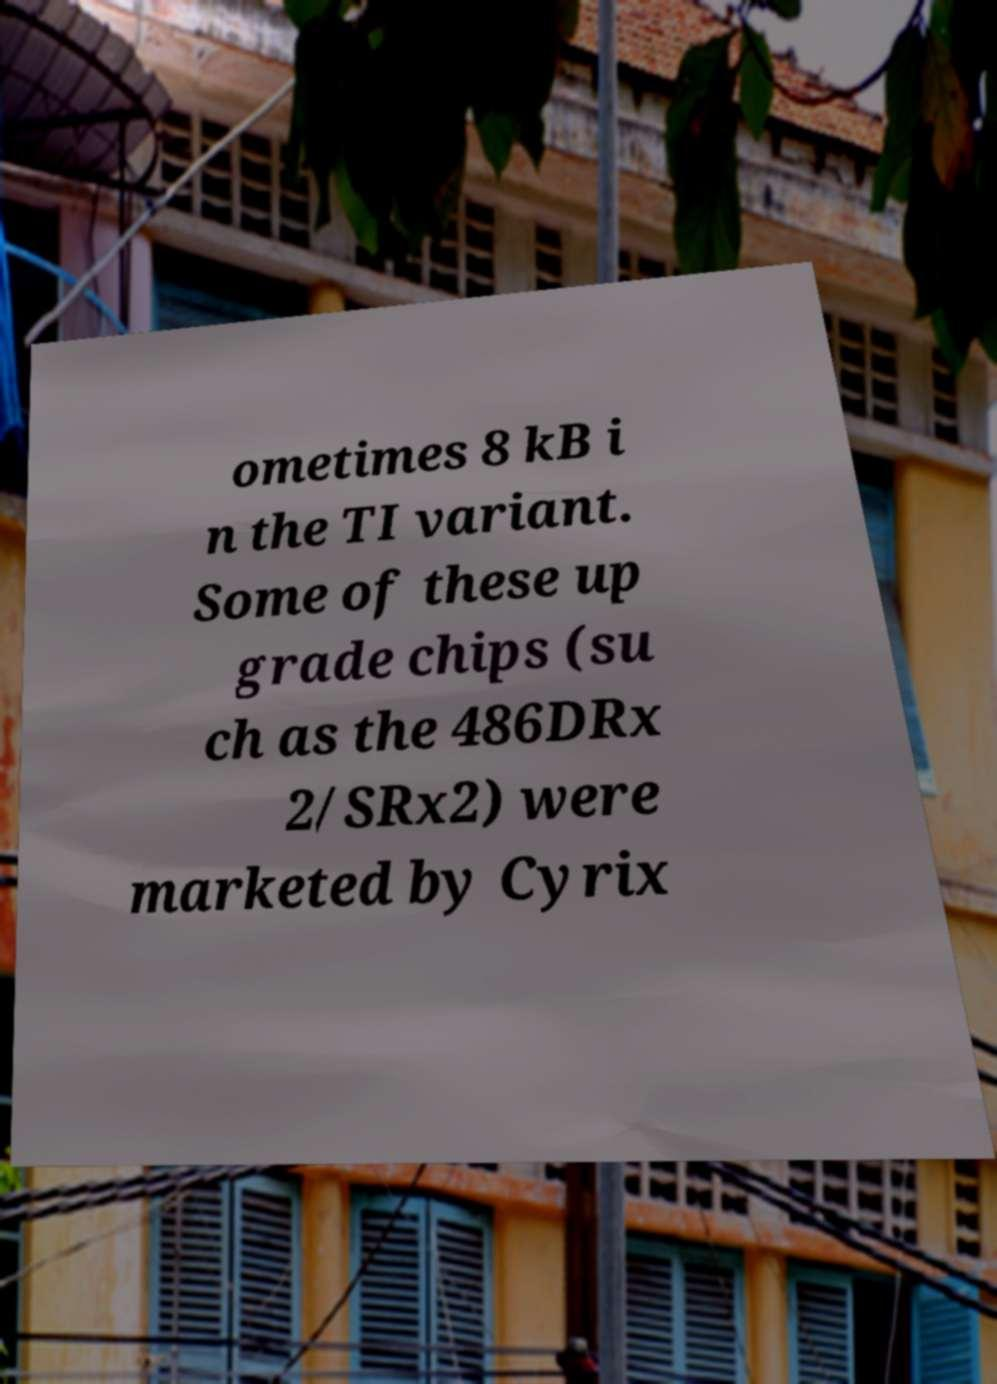I need the written content from this picture converted into text. Can you do that? ometimes 8 kB i n the TI variant. Some of these up grade chips (su ch as the 486DRx 2/SRx2) were marketed by Cyrix 